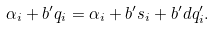Convert formula to latex. <formula><loc_0><loc_0><loc_500><loc_500>\alpha _ { i } + b ^ { \prime } q _ { i } = \alpha _ { i } + b ^ { \prime } s _ { i } + b ^ { \prime } d q _ { i } ^ { \prime } .</formula> 